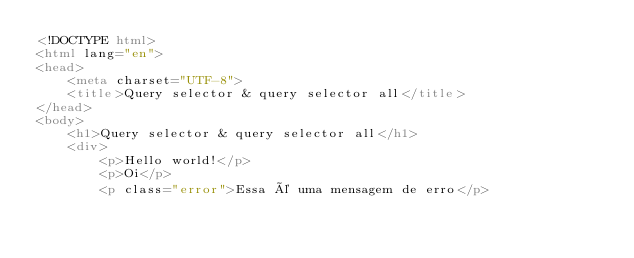Convert code to text. <code><loc_0><loc_0><loc_500><loc_500><_HTML_><!DOCTYPE html>
<html lang="en">
<head>
    <meta charset="UTF-8">
    <title>Query selector & query selector all</title>
</head>
<body>
    <h1>Query selector & query selector all</h1>
    <div>
        <p>Hello world!</p>
        <p>Oi</p>
        <p class="error">Essa é uma mensagem de erro</p></code> 